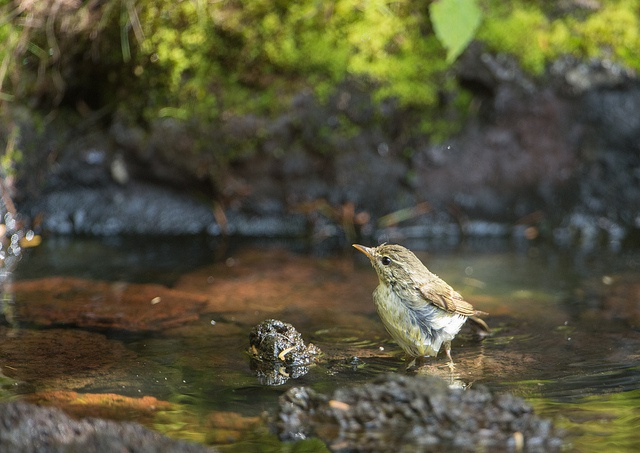Describe the objects in this image and their specific colors. I can see a bird in olive, darkgray, ivory, tan, and gray tones in this image. 